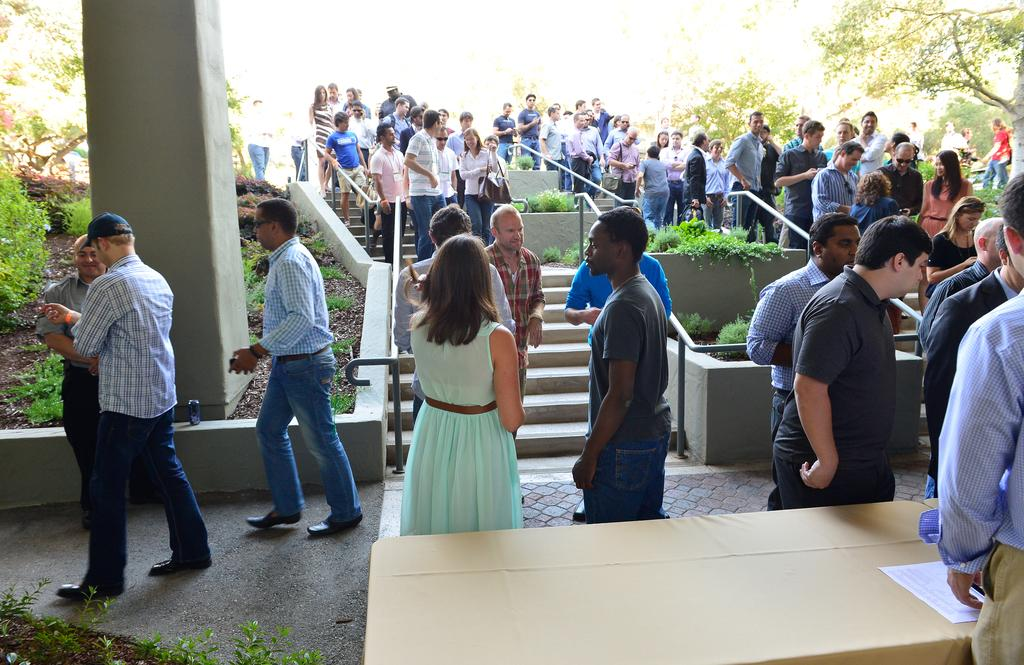What is the main subject of the image? The main subject of the image is a group of people. What are the people in the image doing? The people are standing. What can be seen in the background of the image? There are trees on either side of the group of people. What type of letter is being passed around by the group of people in the image? There is no letter present in the image; it only shows a group of people standing with trees in the background. 